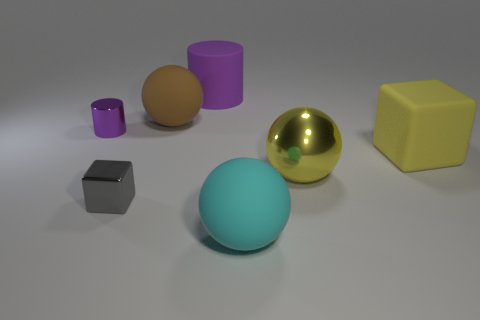What is the size of the metal thing that is the same color as the big cylinder?
Your answer should be very brief. Small. Is there a yellow block that has the same material as the large cyan thing?
Provide a short and direct response. Yes. There is a big sphere on the right side of the large cyan sphere; what is its material?
Offer a terse response. Metal. Is the color of the cube that is on the left side of the large cylinder the same as the large matte object to the left of the purple rubber thing?
Give a very brief answer. No. The block that is the same size as the purple matte cylinder is what color?
Your response must be concise. Yellow. How many other objects are there of the same shape as the yellow metallic thing?
Your answer should be very brief. 2. What size is the ball to the right of the big cyan thing?
Your response must be concise. Large. What number of things are in front of the block that is right of the cyan object?
Provide a short and direct response. 3. How many other things are there of the same size as the shiny block?
Provide a succinct answer. 1. Is the color of the small block the same as the large cylinder?
Provide a succinct answer. No. 